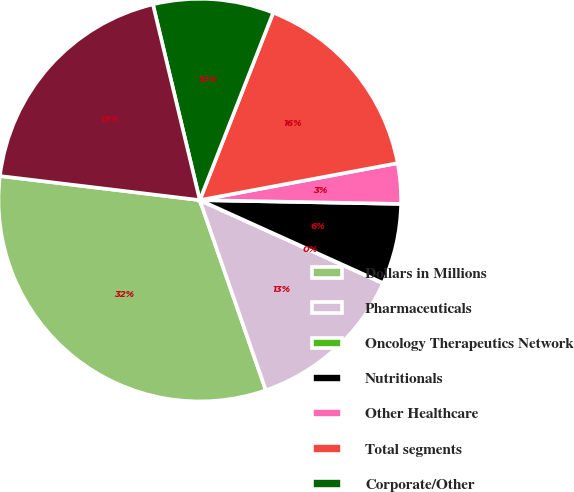Convert chart. <chart><loc_0><loc_0><loc_500><loc_500><pie_chart><fcel>Dollars in Millions<fcel>Pharmaceuticals<fcel>Oncology Therapeutics Network<fcel>Nutritionals<fcel>Other Healthcare<fcel>Total segments<fcel>Corporate/Other<fcel>Total<nl><fcel>32.23%<fcel>12.9%<fcel>0.02%<fcel>6.46%<fcel>3.24%<fcel>16.12%<fcel>9.68%<fcel>19.35%<nl></chart> 